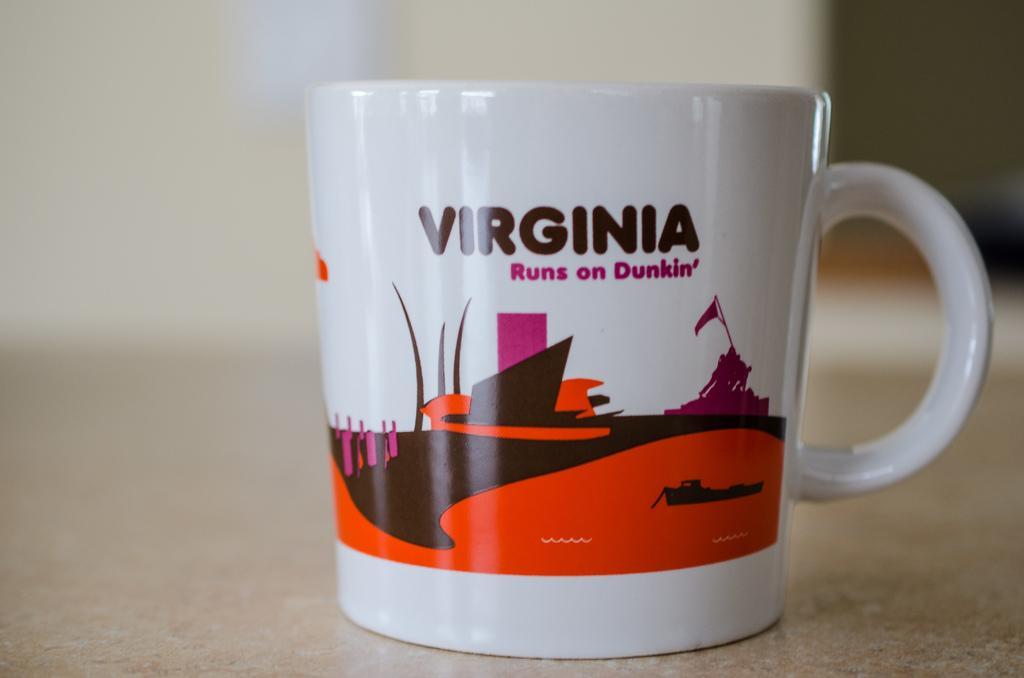Describe this image in one or two sentences. In the center of the image we can see a cup placed on the surface. In the background there is a wall. 